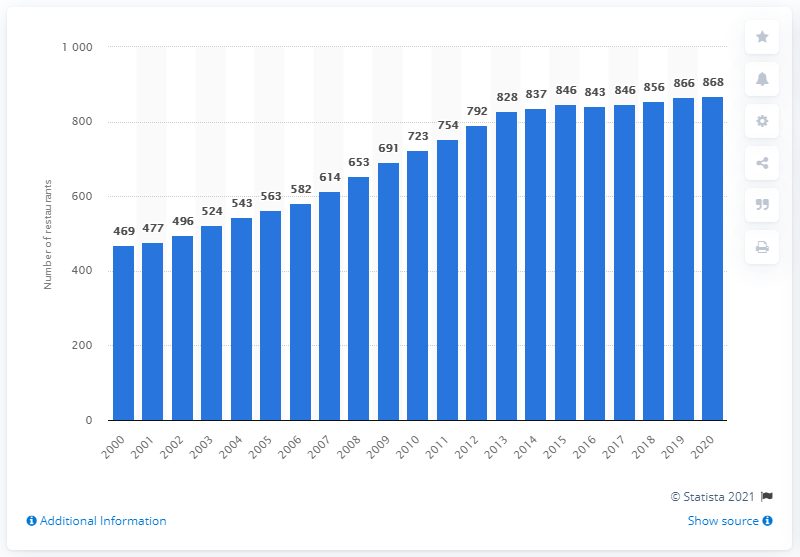Draw attention to some important aspects in this diagram. At the close of the 2020 fiscal year, there were a total of 868 Olive Garden restaurants located in North America. 